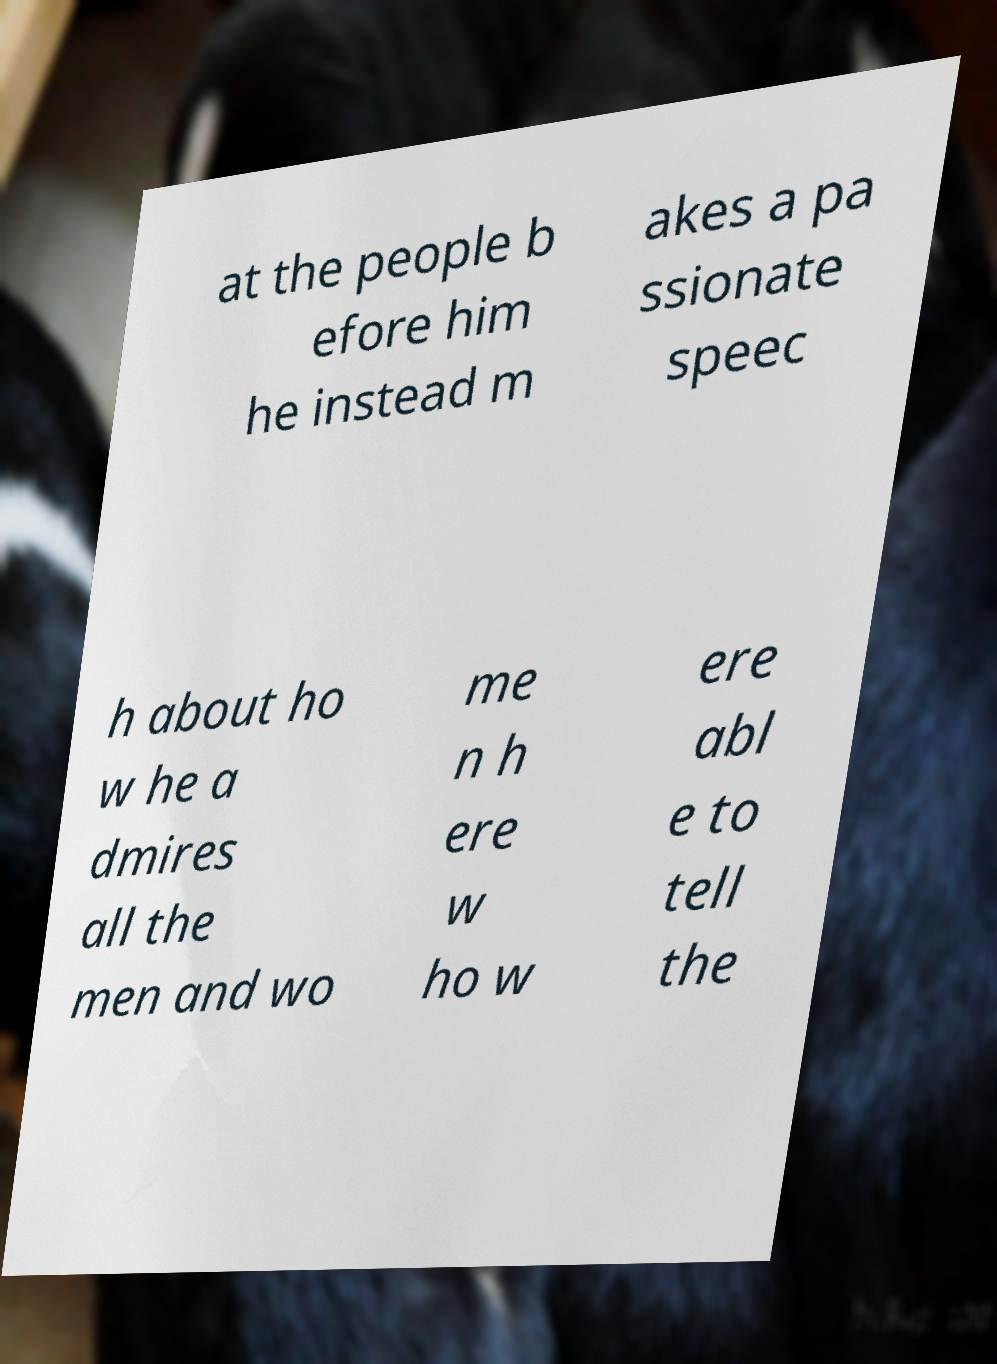Can you read and provide the text displayed in the image?This photo seems to have some interesting text. Can you extract and type it out for me? at the people b efore him he instead m akes a pa ssionate speec h about ho w he a dmires all the men and wo me n h ere w ho w ere abl e to tell the 